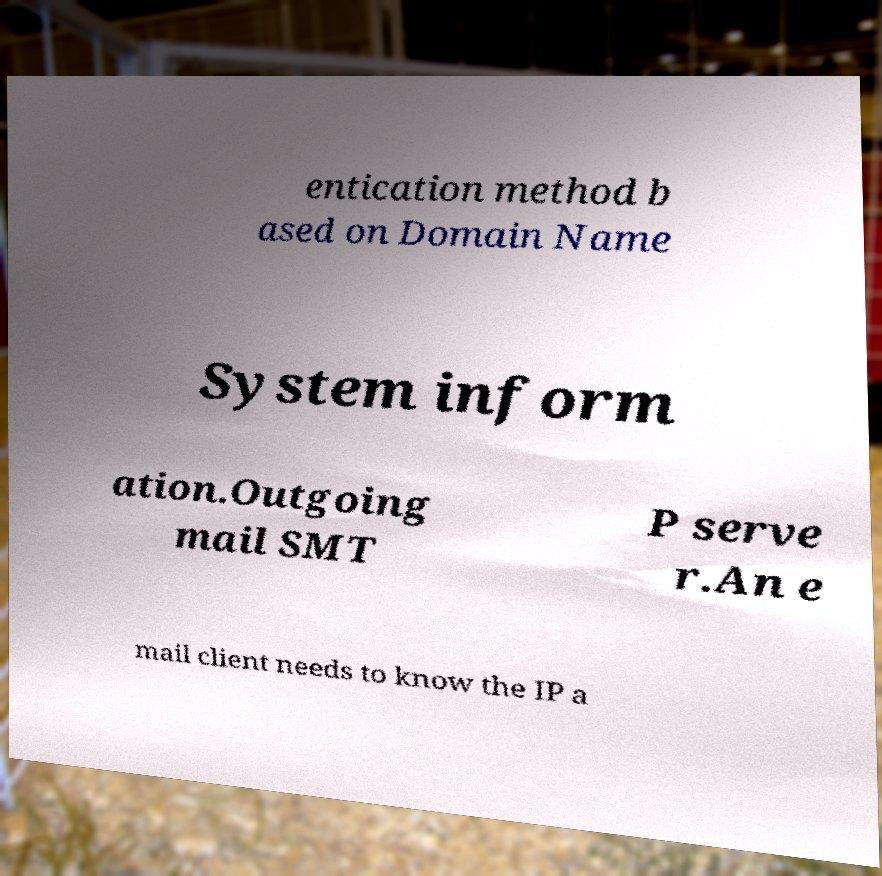For documentation purposes, I need the text within this image transcribed. Could you provide that? entication method b ased on Domain Name System inform ation.Outgoing mail SMT P serve r.An e mail client needs to know the IP a 